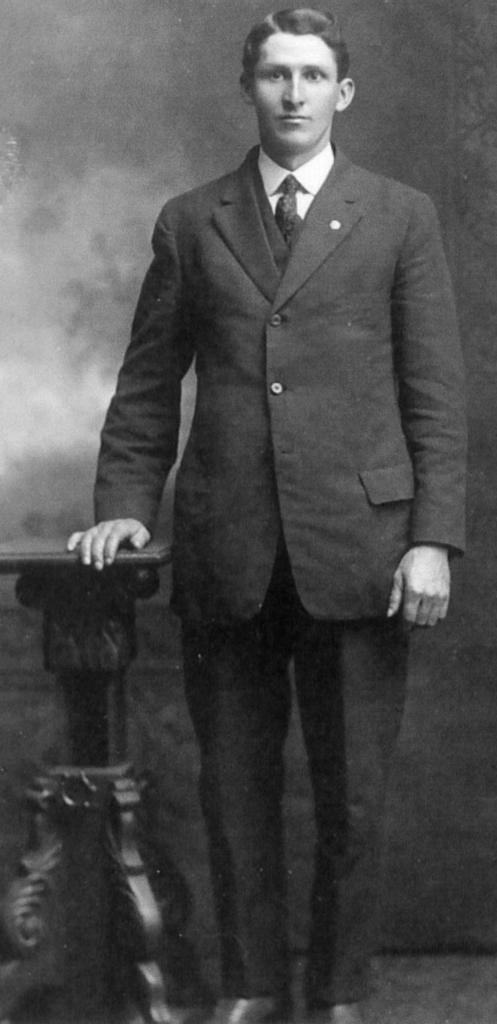What is the main subject of the picture? The main subject of the picture is a man. What is the man doing in the picture? The man is standing in the picture. What is the color scheme of the picture? The photography is in black and white. What type of belief can be seen in the man's eyes in the image? There is no indication of the man's beliefs in the image, as it is a black and white photograph of a man standing. 